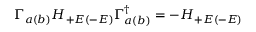<formula> <loc_0><loc_0><loc_500><loc_500>\Gamma _ { a ( b ) } H _ { + E ( - E ) } \Gamma _ { a ( b ) } ^ { \dagger } = - H _ { + E ( - E ) }</formula> 